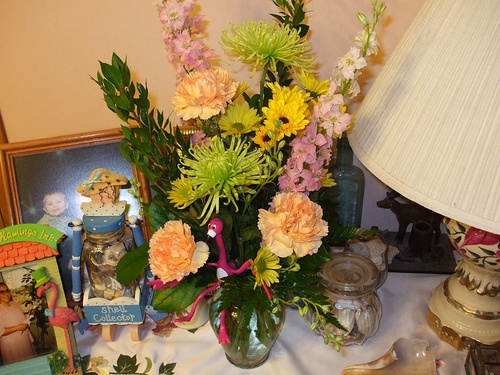Describe the objects in this image and their specific colors. I can see vase in tan, maroon, and gray tones, vase in tan, darkgreen, black, gray, and darkgray tones, bottle in tan, black, purple, darkblue, and gray tones, people in tan, brown, salmon, and maroon tones, and people in tan and darkgray tones in this image. 